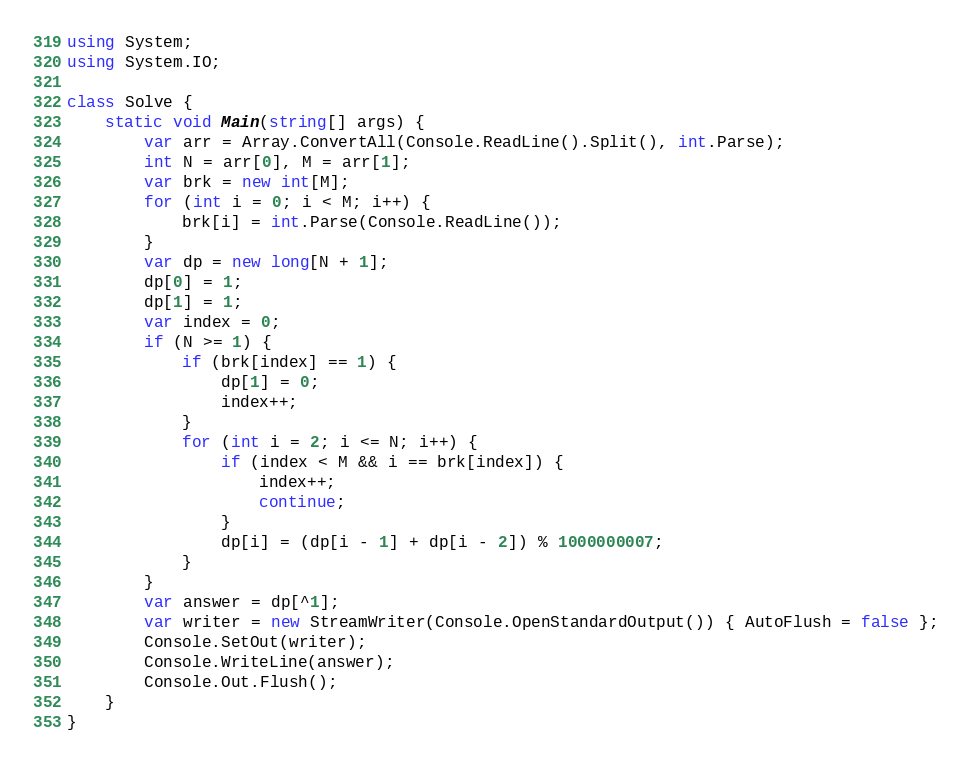Convert code to text. <code><loc_0><loc_0><loc_500><loc_500><_C#_>using System;
using System.IO;

class Solve {
    static void Main(string[] args) {
        var arr = Array.ConvertAll(Console.ReadLine().Split(), int.Parse);
        int N = arr[0], M = arr[1];
        var brk = new int[M];
        for (int i = 0; i < M; i++) {
            brk[i] = int.Parse(Console.ReadLine());
        }
        var dp = new long[N + 1];
        dp[0] = 1;
        dp[1] = 1;
        var index = 0;
        if (N >= 1) {
            if (brk[index] == 1) {
                dp[1] = 0;
                index++;
            }
            for (int i = 2; i <= N; i++) {
                if (index < M && i == brk[index]) {
                    index++;
                    continue;
                }
                dp[i] = (dp[i - 1] + dp[i - 2]) % 1000000007;
            }   
        }
        var answer = dp[^1];
        var writer = new StreamWriter(Console.OpenStandardOutput()) { AutoFlush = false };
        Console.SetOut(writer);
        Console.WriteLine(answer);
        Console.Out.Flush();
    }
}</code> 